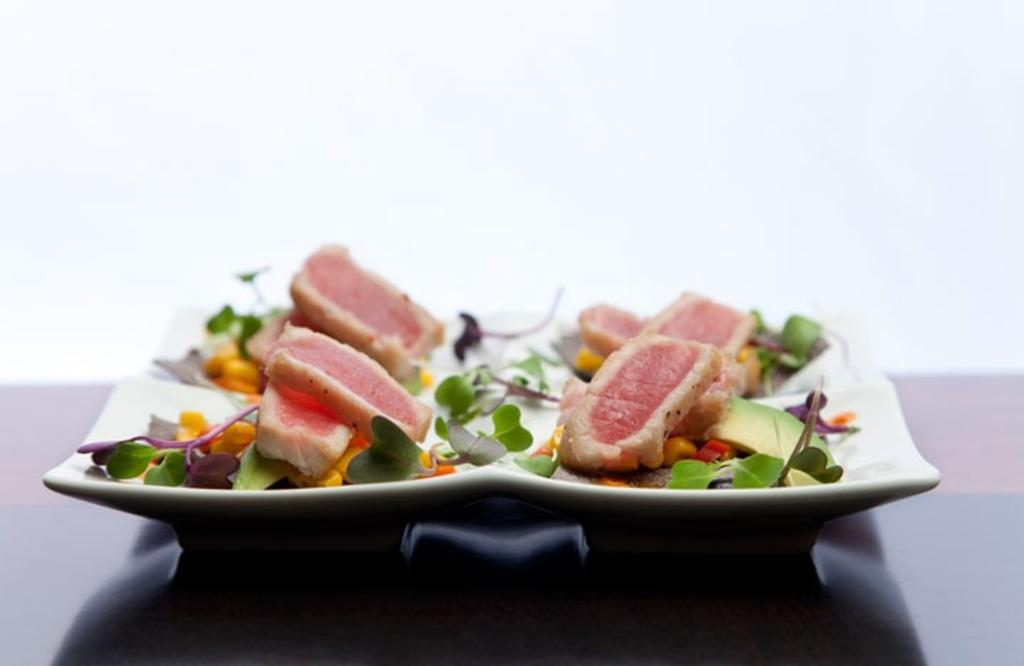What is the main subject of the image? There is a food item in the image. How is the food item presented? The food item is on a plate. Where is the plate located? The plate is placed on a table. What emotion does the rabbit in the image display? There is no rabbit present in the image, so it is not possible to determine the emotion it might display. 